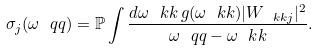<formula> <loc_0><loc_0><loc_500><loc_500>\sigma _ { j } ( \omega _ { \ } q q ) = { \mathbb { P } } \int \frac { d \omega _ { \ } k k \, g ( \omega _ { \ } k k ) | W _ { \ k k j } | ^ { 2 } } { \omega _ { \ } q q - \omega _ { \ } k k } .</formula> 